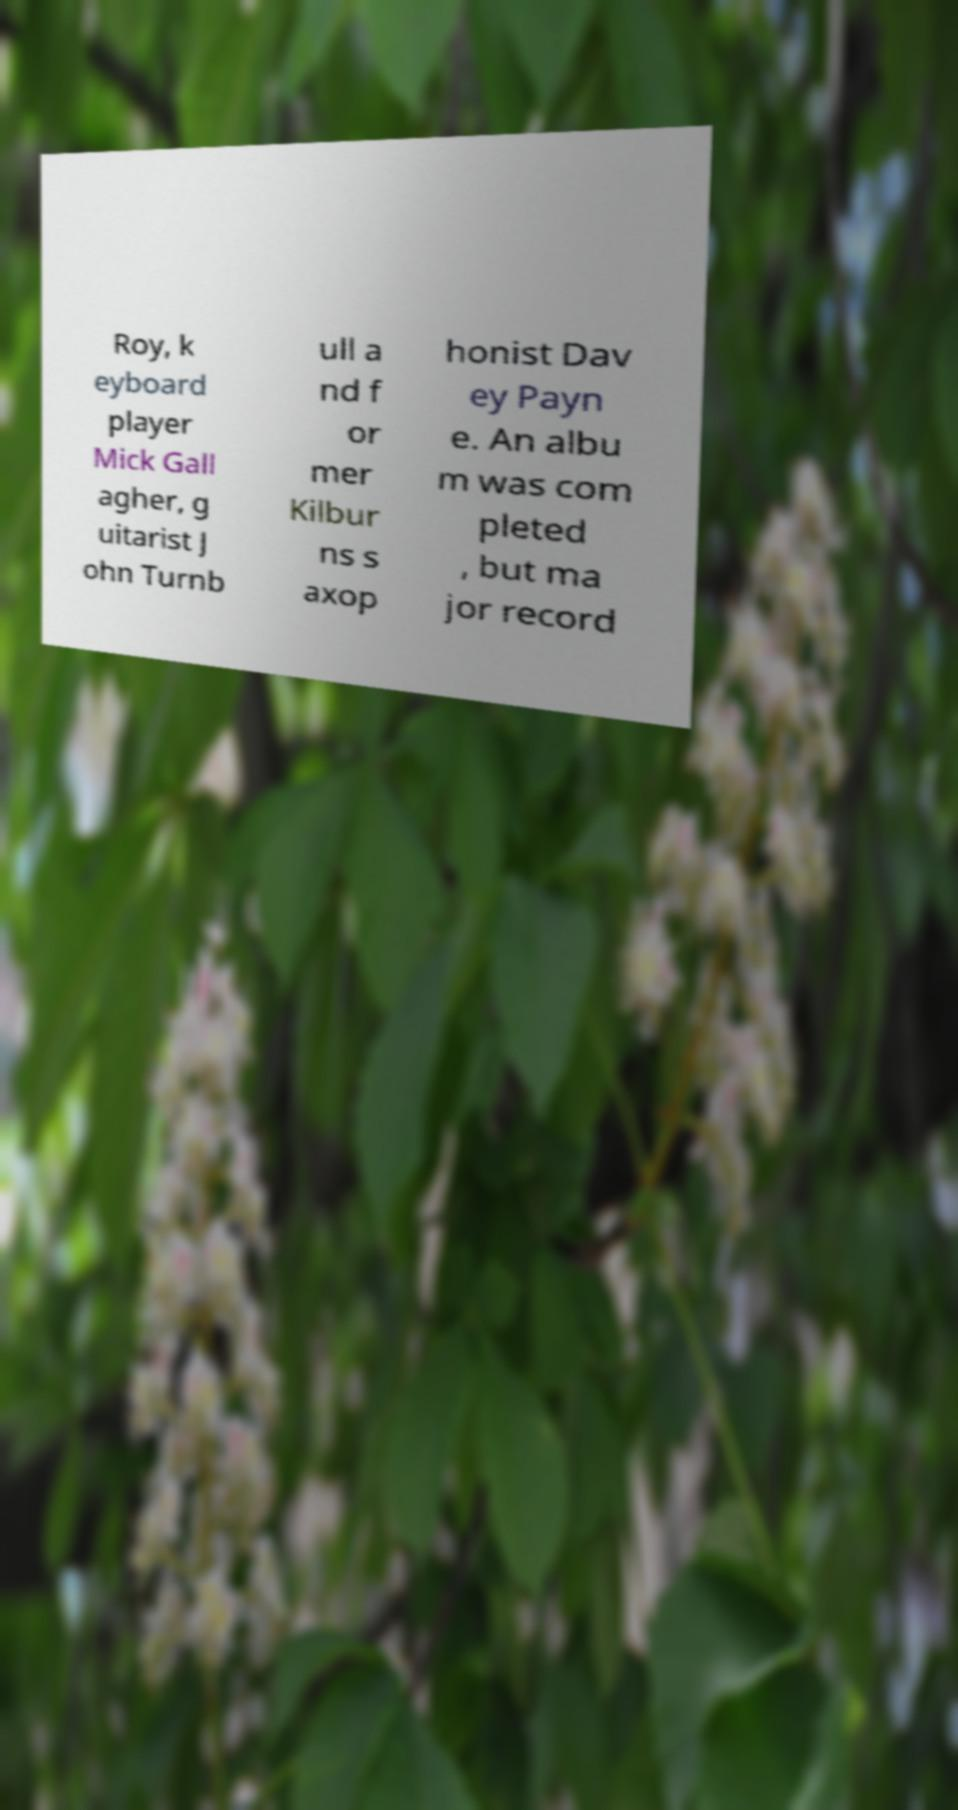Could you assist in decoding the text presented in this image and type it out clearly? Roy, k eyboard player Mick Gall agher, g uitarist J ohn Turnb ull a nd f or mer Kilbur ns s axop honist Dav ey Payn e. An albu m was com pleted , but ma jor record 